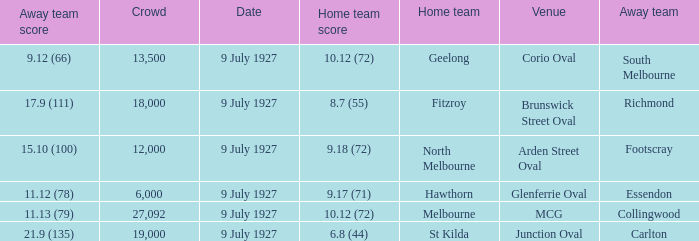What was the venue where Fitzroy played as the home team? Brunswick Street Oval. Write the full table. {'header': ['Away team score', 'Crowd', 'Date', 'Home team score', 'Home team', 'Venue', 'Away team'], 'rows': [['9.12 (66)', '13,500', '9 July 1927', '10.12 (72)', 'Geelong', 'Corio Oval', 'South Melbourne'], ['17.9 (111)', '18,000', '9 July 1927', '8.7 (55)', 'Fitzroy', 'Brunswick Street Oval', 'Richmond'], ['15.10 (100)', '12,000', '9 July 1927', '9.18 (72)', 'North Melbourne', 'Arden Street Oval', 'Footscray'], ['11.12 (78)', '6,000', '9 July 1927', '9.17 (71)', 'Hawthorn', 'Glenferrie Oval', 'Essendon'], ['11.13 (79)', '27,092', '9 July 1927', '10.12 (72)', 'Melbourne', 'MCG', 'Collingwood'], ['21.9 (135)', '19,000', '9 July 1927', '6.8 (44)', 'St Kilda', 'Junction Oval', 'Carlton']]} 